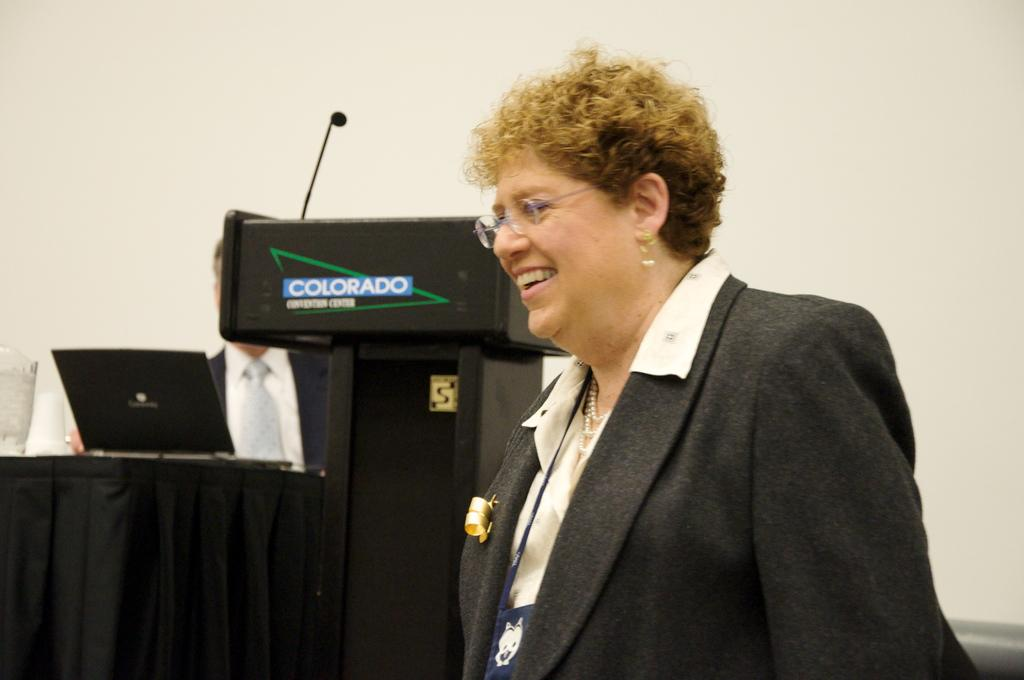Who is the main subject in the image? There is a lady in the center of the image. What can be seen in the background of the image? There is a wall in the background of the image. What object is present in the image that might be used for speaking or presenting? There is a podium in the image. What electronic device is visible on a table in the image? There is a laptop on a table in the image. What type of engine can be seen in the image? There is no engine present in the image. What kind of humor is being displayed by the lady in the image? There is no indication of humor in the image; it simply shows a lady standing near a podium and a laptop on a table. 